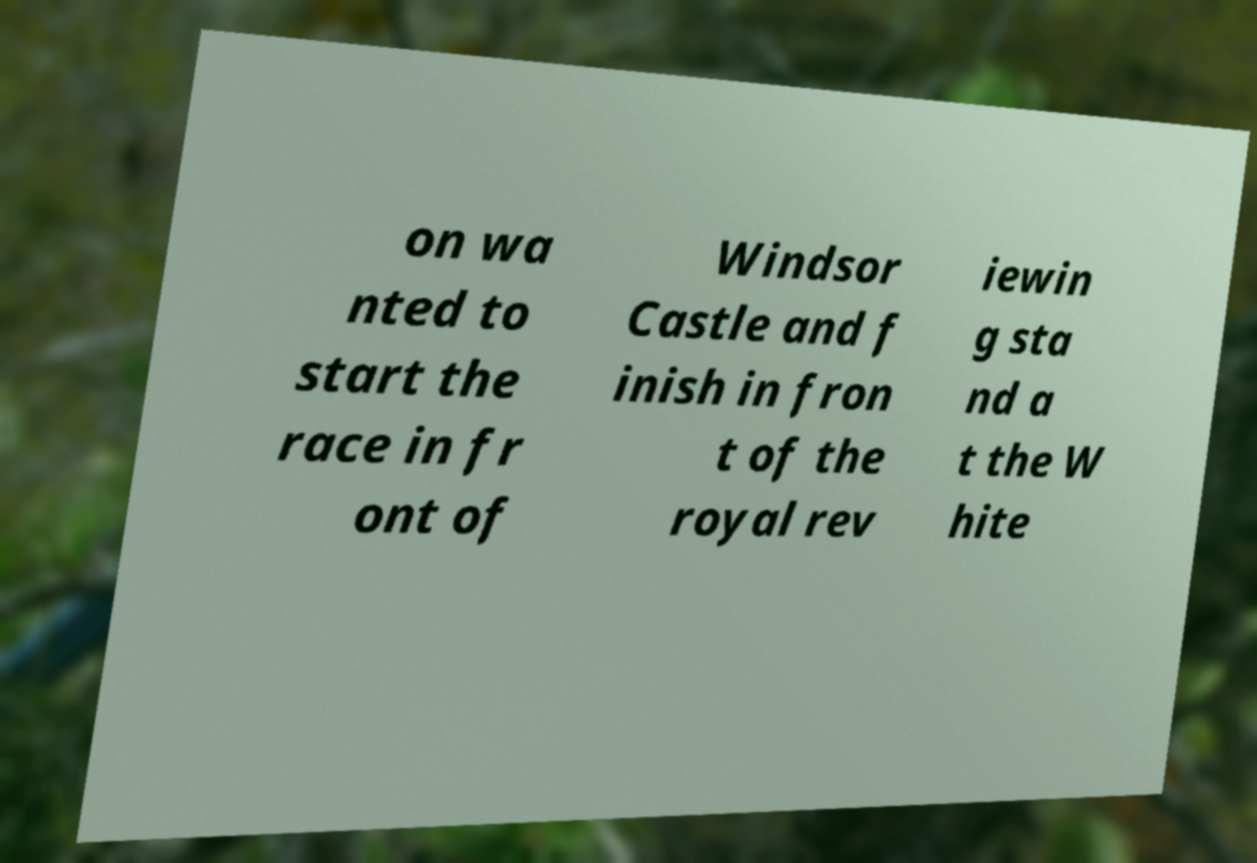I need the written content from this picture converted into text. Can you do that? on wa nted to start the race in fr ont of Windsor Castle and f inish in fron t of the royal rev iewin g sta nd a t the W hite 